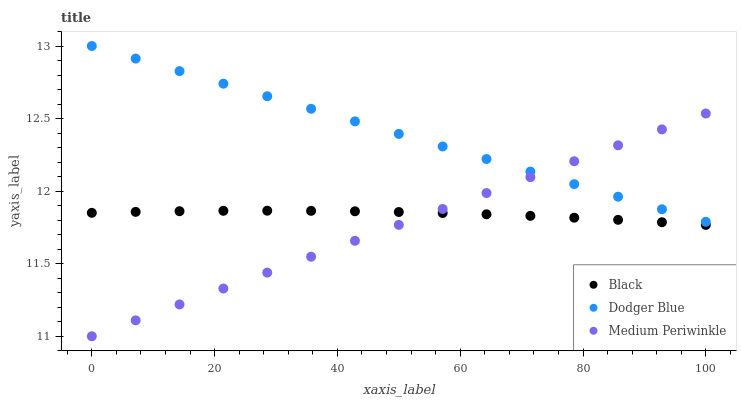Does Medium Periwinkle have the minimum area under the curve?
Answer yes or no. Yes. Does Dodger Blue have the maximum area under the curve?
Answer yes or no. Yes. Does Black have the minimum area under the curve?
Answer yes or no. No. Does Black have the maximum area under the curve?
Answer yes or no. No. Is Dodger Blue the smoothest?
Answer yes or no. Yes. Is Black the roughest?
Answer yes or no. Yes. Is Medium Periwinkle the smoothest?
Answer yes or no. No. Is Medium Periwinkle the roughest?
Answer yes or no. No. Does Medium Periwinkle have the lowest value?
Answer yes or no. Yes. Does Black have the lowest value?
Answer yes or no. No. Does Dodger Blue have the highest value?
Answer yes or no. Yes. Does Medium Periwinkle have the highest value?
Answer yes or no. No. Is Black less than Dodger Blue?
Answer yes or no. Yes. Is Dodger Blue greater than Black?
Answer yes or no. Yes. Does Black intersect Medium Periwinkle?
Answer yes or no. Yes. Is Black less than Medium Periwinkle?
Answer yes or no. No. Is Black greater than Medium Periwinkle?
Answer yes or no. No. Does Black intersect Dodger Blue?
Answer yes or no. No. 